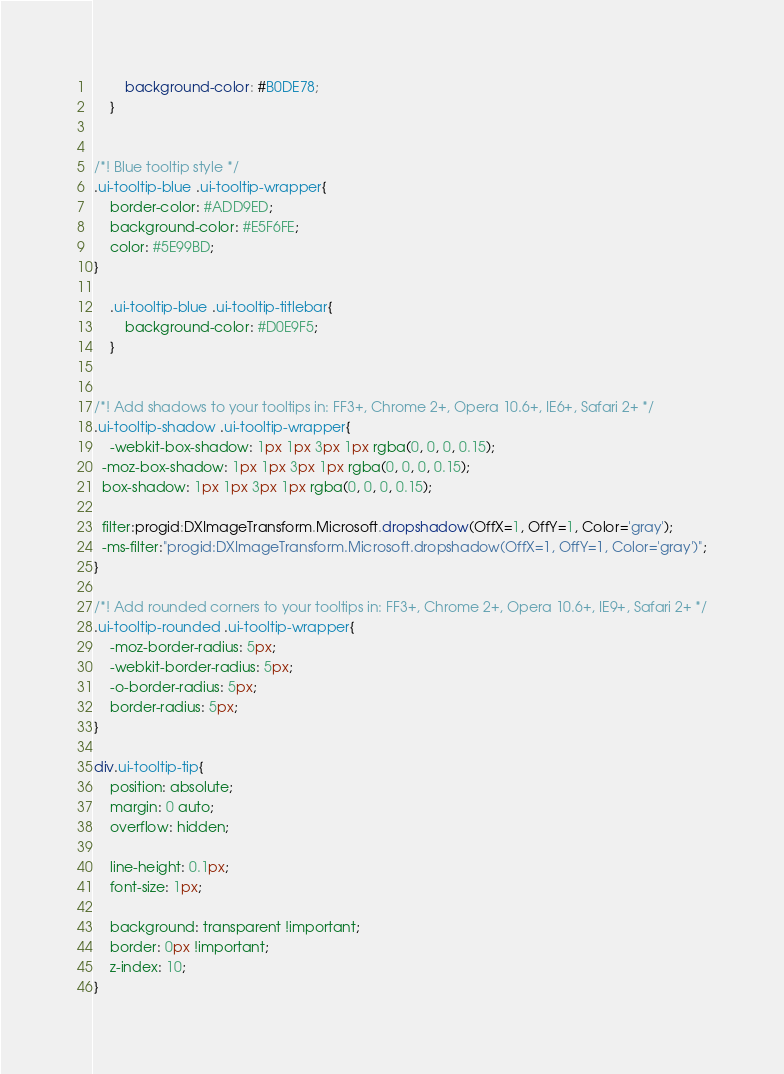Convert code to text. <code><loc_0><loc_0><loc_500><loc_500><_CSS_>		background-color: #B0DE78;
	}


/*! Blue tooltip style */
.ui-tooltip-blue .ui-tooltip-wrapper{
	border-color: #ADD9ED;
	background-color: #E5F6FE;
	color: #5E99BD;
}

	.ui-tooltip-blue .ui-tooltip-titlebar{
		background-color: #D0E9F5;
	}


/*! Add shadows to your tooltips in: FF3+, Chrome 2+, Opera 10.6+, IE6+, Safari 2+ */
.ui-tooltip-shadow .ui-tooltip-wrapper{
	-webkit-box-shadow: 1px 1px 3px 1px rgba(0, 0, 0, 0.15);
  -moz-box-shadow: 1px 1px 3px 1px rgba(0, 0, 0, 0.15);
  box-shadow: 1px 1px 3px 1px rgba(0, 0, 0, 0.15);

  filter:progid:DXImageTransform.Microsoft.dropshadow(OffX=1, OffY=1, Color='gray');
  -ms-filter:"progid:DXImageTransform.Microsoft.dropshadow(OffX=1, OffY=1, Color='gray')";
}

/*! Add rounded corners to your tooltips in: FF3+, Chrome 2+, Opera 10.6+, IE9+, Safari 2+ */
.ui-tooltip-rounded .ui-tooltip-wrapper{
	-moz-border-radius: 5px;
	-webkit-border-radius: 5px;
	-o-border-radius: 5px;
	border-radius: 5px;
}

div.ui-tooltip-tip{
	position: absolute;
	margin: 0 auto;
	overflow: hidden;

	line-height: 0.1px;
	font-size: 1px;

	background: transparent !important;
	border: 0px !important;
	z-index: 10;
}
</code> 